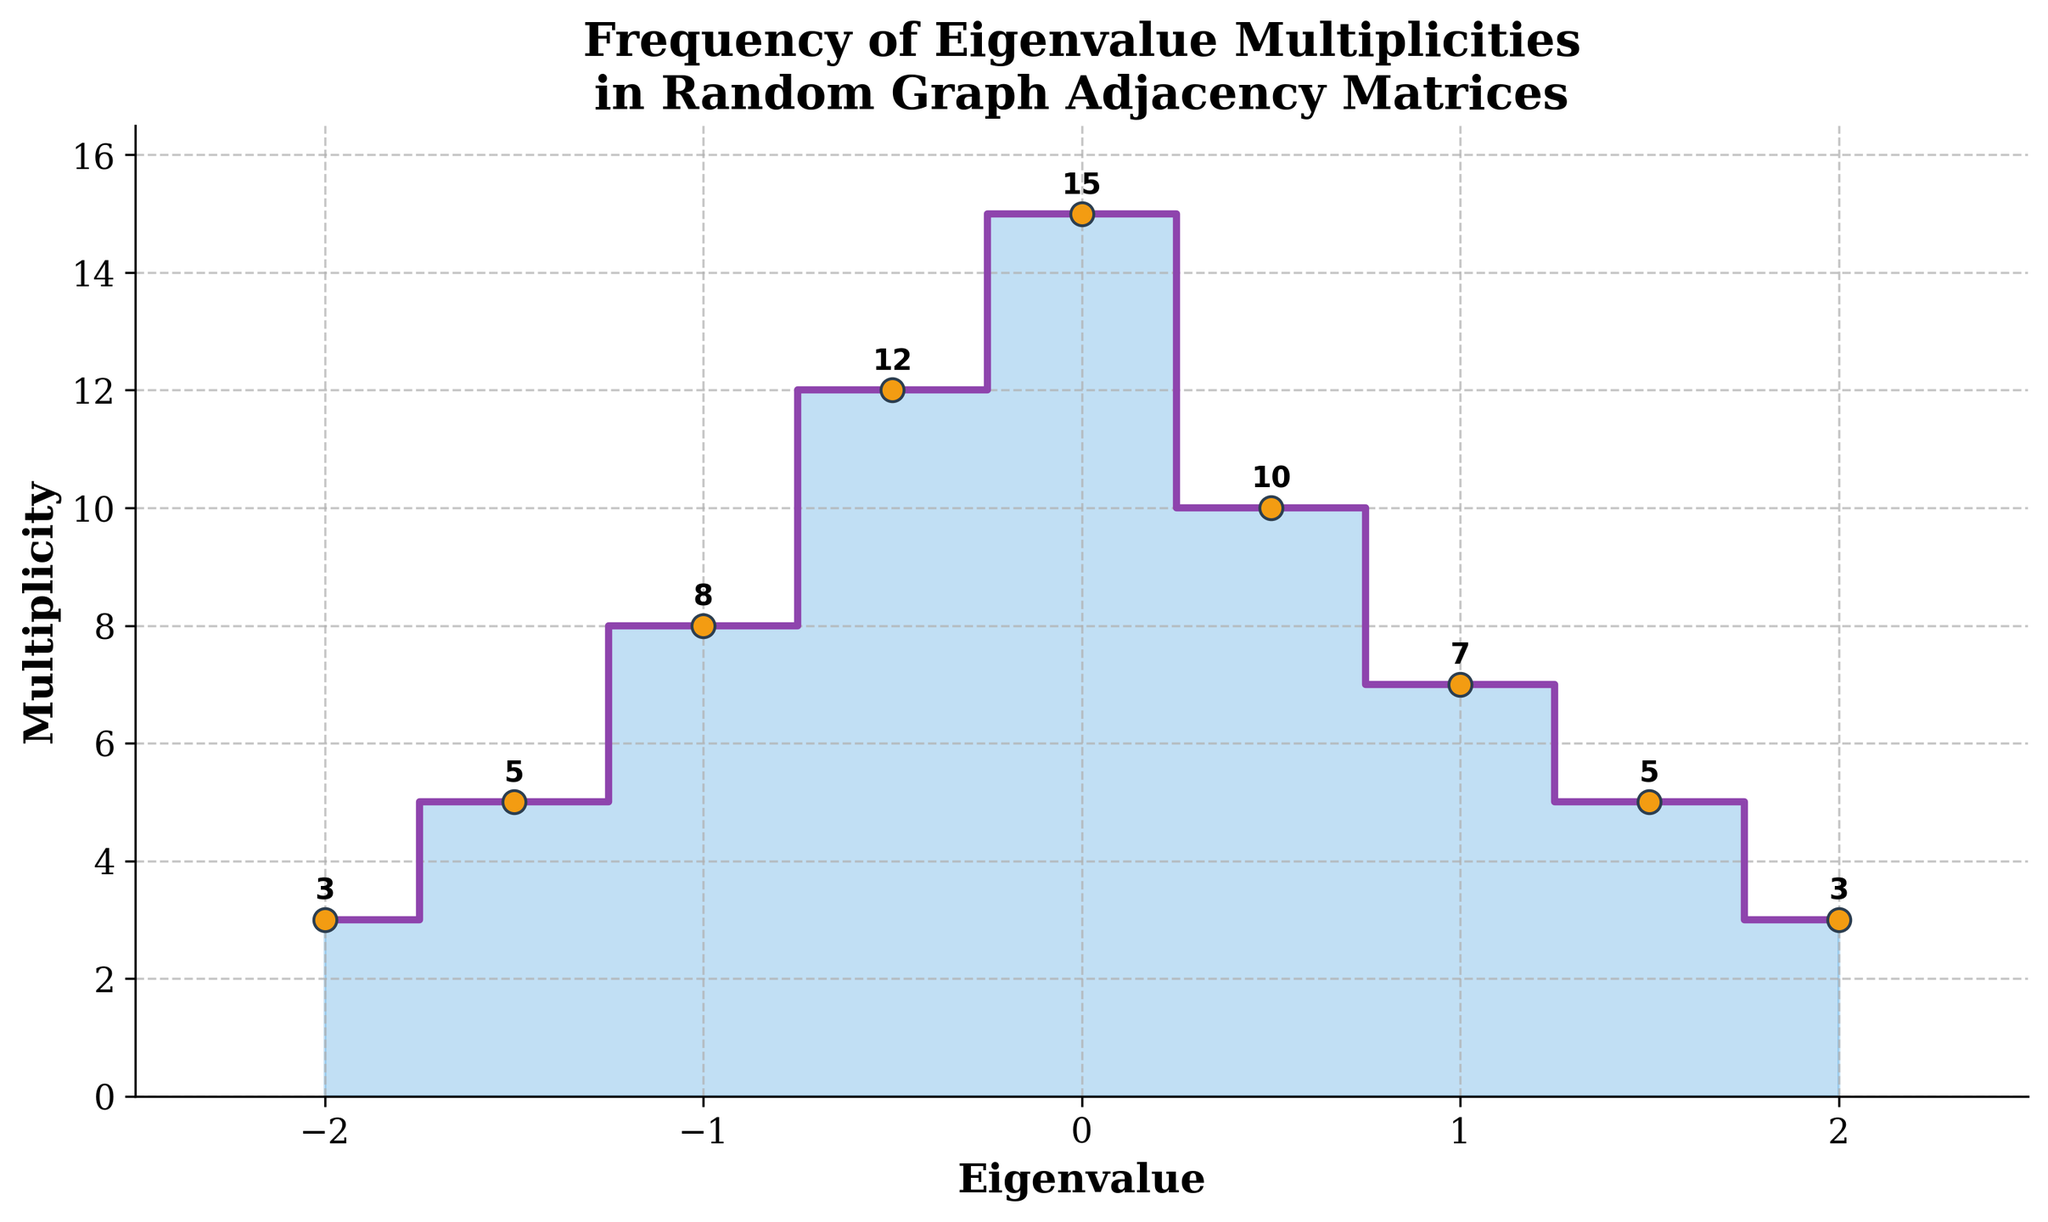What's the title of the figure? The title of the figure can be found at the top of the plot, which describes the contents or purpose of the figure
Answer: Frequency of Eigenvalue Multiplicities in Random Graph Adjacency Matrices What are the axis labels in the figure? The axis labels are typically found alongside the axes, describing what each axis represents. The x-axis label is at the bottom, and the y-axis label is on the left side
Answer: Eigenvalue (x-axis), Multiplicity (y-axis) What is the highest multiplicity value in the figure and which eigenvalue does it correspond to? The highest multiplicity value on the y-axis can be identified by finding the peak value. It is labeled with an annotation at the top of the respective step.
Answer: 15, eigenvalue 0 What is the sum of the multiplicities for eigenvalues greater than 0? Identify the multiplicities for eigenvalues 0.5, 1, 1.5, and 2, and sum them up: 10 + 7 + 5 + 3
Answer: 25 Which two eigenvalues have the same multiplicity and what is that multiplicity? By examining the plot, look for eigenvalues that have the same y-axis value. Eigenvalues 1.5 and -1.5 both have a multiplicity of 5
Answer: 1.5 and -1.5, multiplicity 5 What is the range of the eigenvalues represented in the figure? The range can be calculated by subtracting the smallest eigenvalue from the largest eigenvalue. The smallest is -2 and the largest is 2
Answer: 2 - (-2) = 4 Which eigenvalue corresponds to the smallest non-zero multiplicity, and what is that multiplicity? Scan the plot for the smallest non-zero multiplicity value and note the corresponding eigenvalue
Answer: -2 and 2, multiplicity 3 Compare the multiplicities of eigenvalues -1 and 1. Which is greater and by how much? Find and compare the multiplicities at eigenvalues -1 and 1. The plot shows 8 for -1 and 7 for 1, so -1 is greater by 1
Answer: -1 is greater by 1 What is the average multiplicity of all eigenvalues? Sum all multiplicities: 3 + 5 + 8 + 12 + 15 + 10 + 7 + 5 + 3 = 68, then divide by the number of eigenvalues, which is 9
Answer: 68 / 9 ≈ 7.56 